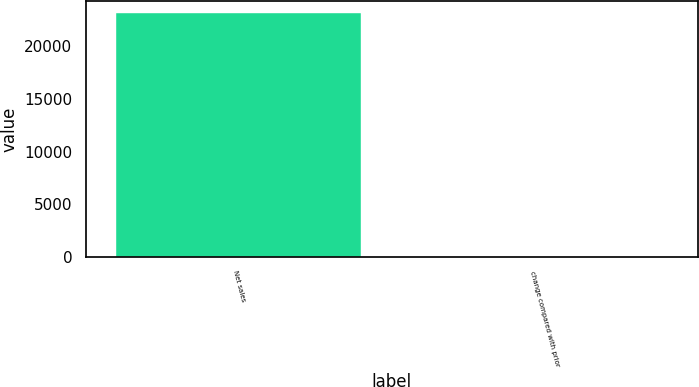Convert chart to OTSL. <chart><loc_0><loc_0><loc_500><loc_500><bar_chart><fcel>Net sales<fcel>change compared with prior<nl><fcel>23103<fcel>4<nl></chart> 